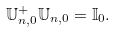<formula> <loc_0><loc_0><loc_500><loc_500>\mathbb { U } _ { n , 0 } ^ { + } \mathbb { U } _ { n , 0 } = \mathbb { I } _ { 0 } .</formula> 